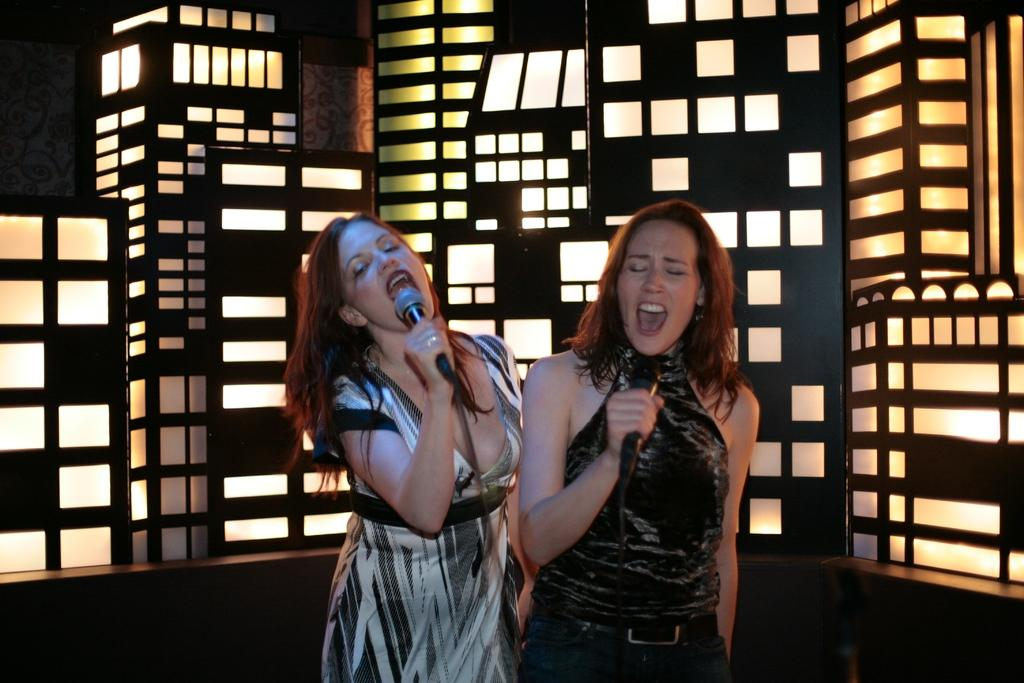How many people are in the image? There are two women in the image. What are the women wearing? The women are wearing clothes. What are the women holding in their hands? The women are holding microphones. What activity are the women engaged in? The women are singing. What can be seen in the image that provides illumination? There is a light visible in the image. Can you see a quill being used by one of the women in the image? No, there is no quill present in the image. How does the orange contribute to the performance in the image? There is no orange present in the image, so it cannot contribute to the performance. 